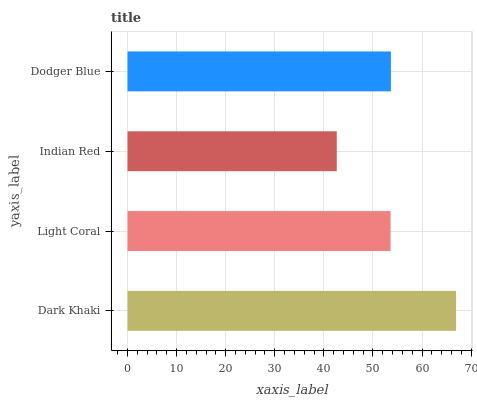Is Indian Red the minimum?
Answer yes or no. Yes. Is Dark Khaki the maximum?
Answer yes or no. Yes. Is Light Coral the minimum?
Answer yes or no. No. Is Light Coral the maximum?
Answer yes or no. No. Is Dark Khaki greater than Light Coral?
Answer yes or no. Yes. Is Light Coral less than Dark Khaki?
Answer yes or no. Yes. Is Light Coral greater than Dark Khaki?
Answer yes or no. No. Is Dark Khaki less than Light Coral?
Answer yes or no. No. Is Dodger Blue the high median?
Answer yes or no. Yes. Is Light Coral the low median?
Answer yes or no. Yes. Is Indian Red the high median?
Answer yes or no. No. Is Dark Khaki the low median?
Answer yes or no. No. 